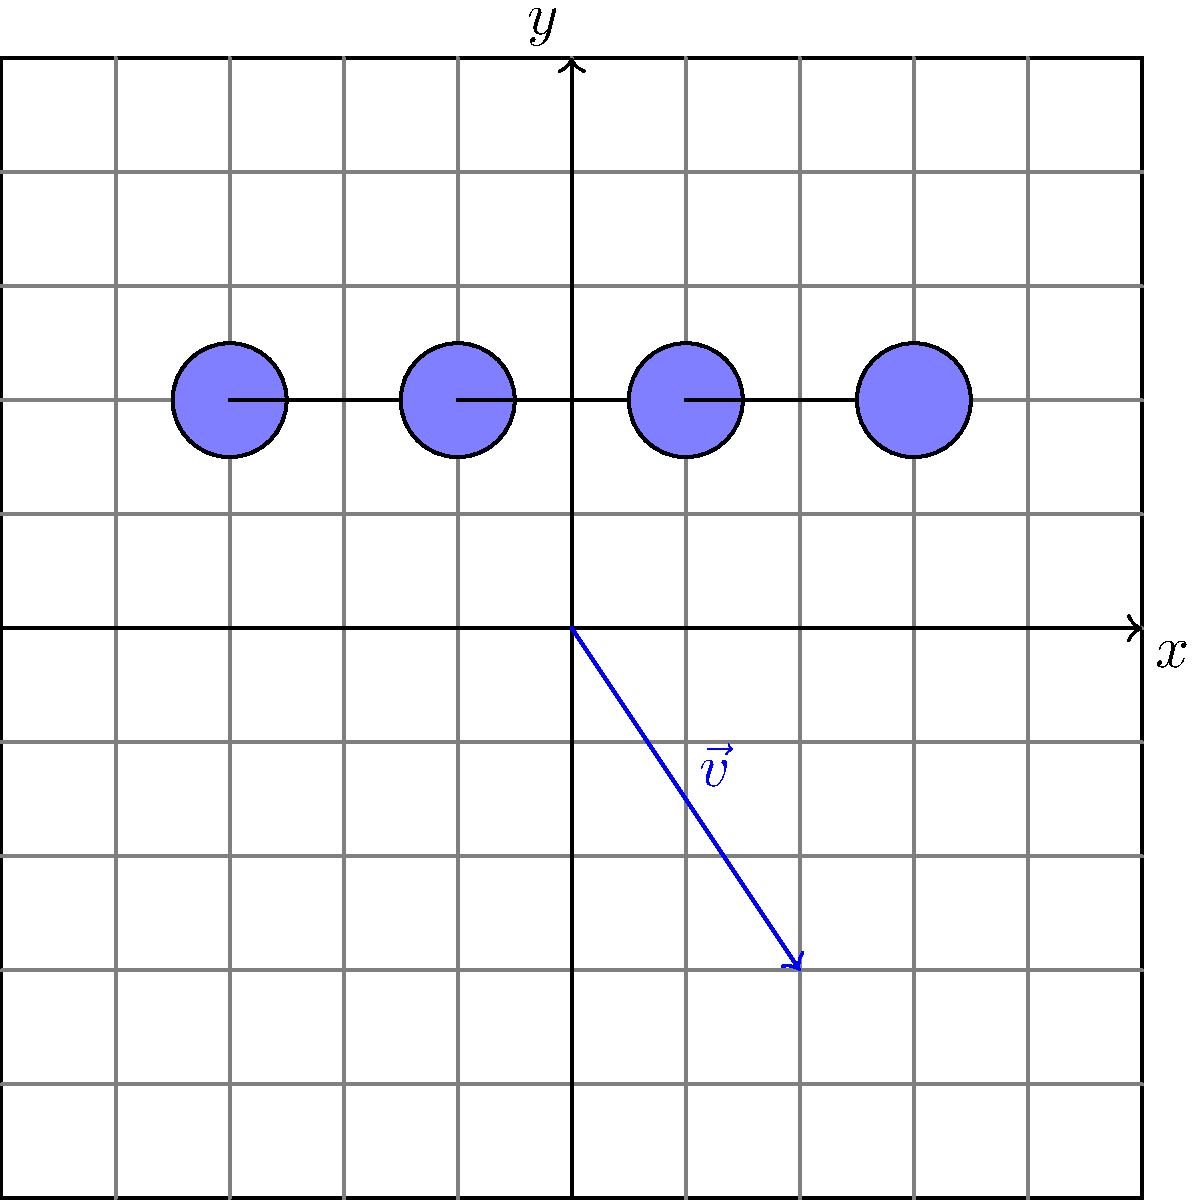A blockchain diagram is represented on a coordinate plane as shown above. If the blockchain is translated by vector $\vec{v} = \langle 2, -3 \rangle$, what will be the coordinates of the first node (leftmost) in the translated diagram? To solve this problem, we need to follow these steps:

1. Identify the coordinates of the first node in the original blockchain diagram:
   The first (leftmost) node is located at $(-3, 2)$.

2. Understand the translation vector:
   The translation vector $\vec{v} = \langle 2, -3 \rangle$ means we need to move:
   - 2 units in the positive x-direction
   - 3 units in the negative y-direction

3. Apply the translation to the first node:
   - Original x-coordinate: $-3$
   - New x-coordinate: $-3 + 2 = -1$
   - Original y-coordinate: $2$
   - New y-coordinate: $2 + (-3) = -1$

4. Combine the new coordinates:
   The translated coordinates of the first node will be $(-1, -1)$.
Answer: $(-1, -1)$ 